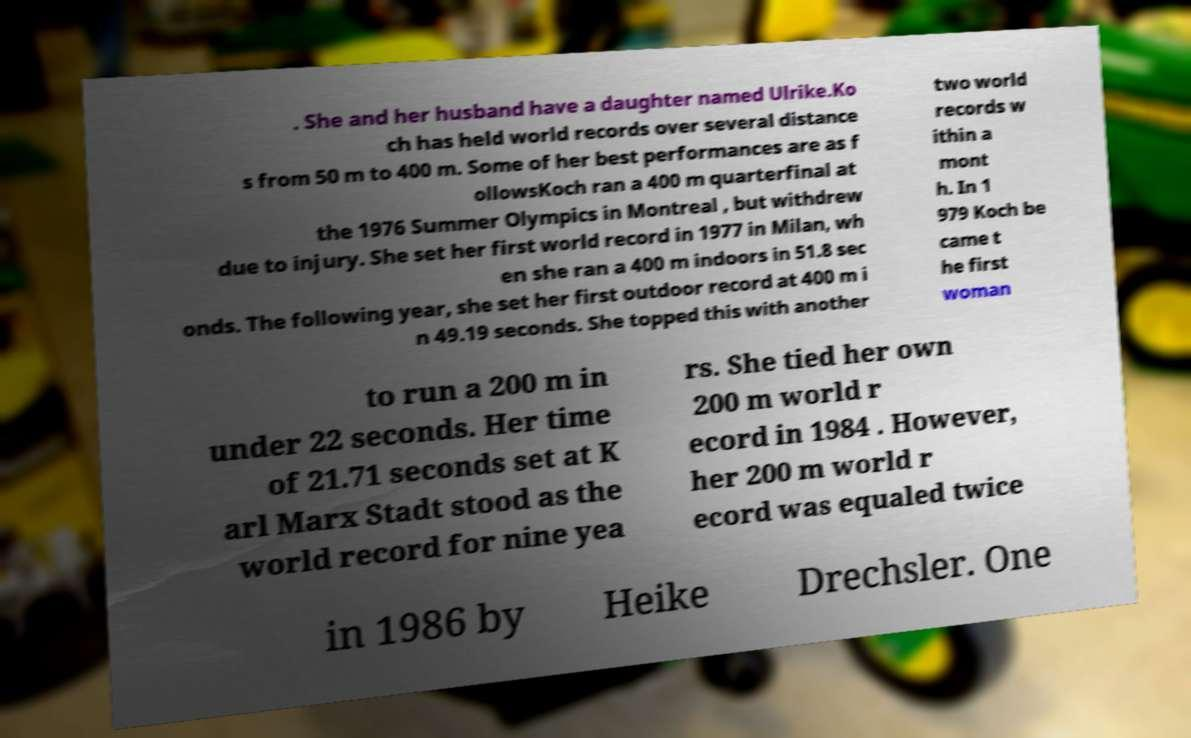Could you assist in decoding the text presented in this image and type it out clearly? . She and her husband have a daughter named Ulrike.Ko ch has held world records over several distance s from 50 m to 400 m. Some of her best performances are as f ollowsKoch ran a 400 m quarterfinal at the 1976 Summer Olympics in Montreal , but withdrew due to injury. She set her first world record in 1977 in Milan, wh en she ran a 400 m indoors in 51.8 sec onds. The following year, she set her first outdoor record at 400 m i n 49.19 seconds. She topped this with another two world records w ithin a mont h. In 1 979 Koch be came t he first woman to run a 200 m in under 22 seconds. Her time of 21.71 seconds set at K arl Marx Stadt stood as the world record for nine yea rs. She tied her own 200 m world r ecord in 1984 . However, her 200 m world r ecord was equaled twice in 1986 by Heike Drechsler. One 